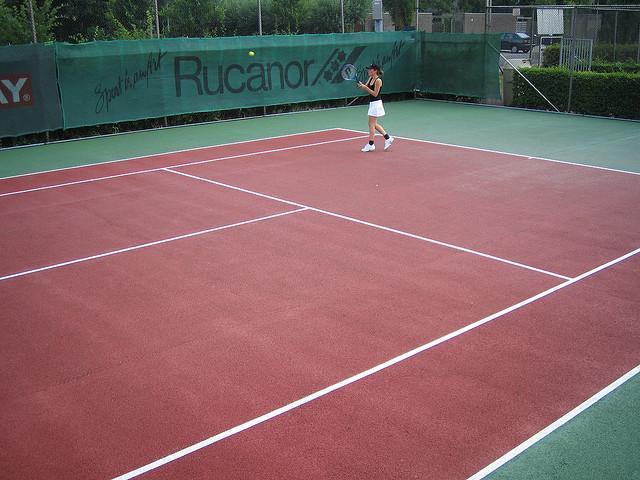How many chairs are there?
Give a very brief answer. 0. 